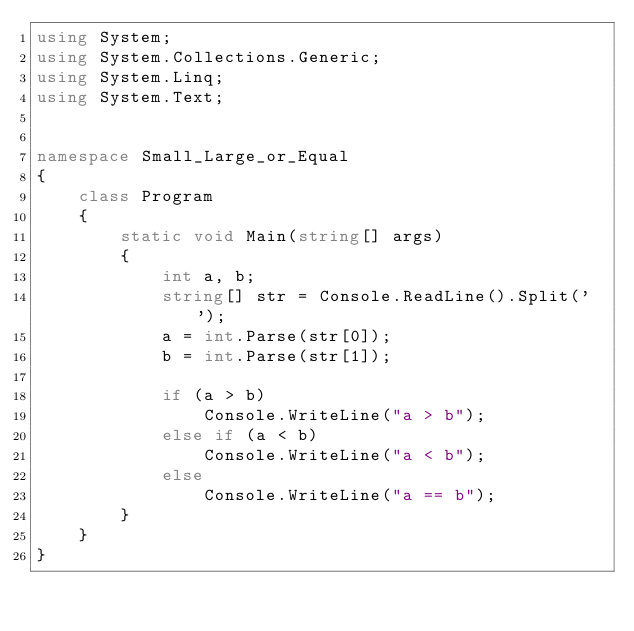Convert code to text. <code><loc_0><loc_0><loc_500><loc_500><_C#_>using System;
using System.Collections.Generic;
using System.Linq;
using System.Text;


namespace Small_Large_or_Equal
{
    class Program
    {
        static void Main(string[] args)
        {
            int a, b;
            string[] str = Console.ReadLine().Split(' ');
            a = int.Parse(str[0]);
            b = int.Parse(str[1]);

            if (a > b)
                Console.WriteLine("a > b");
            else if (a < b)
                Console.WriteLine("a < b");
            else
                Console.WriteLine("a == b");
        }
    }
}</code> 